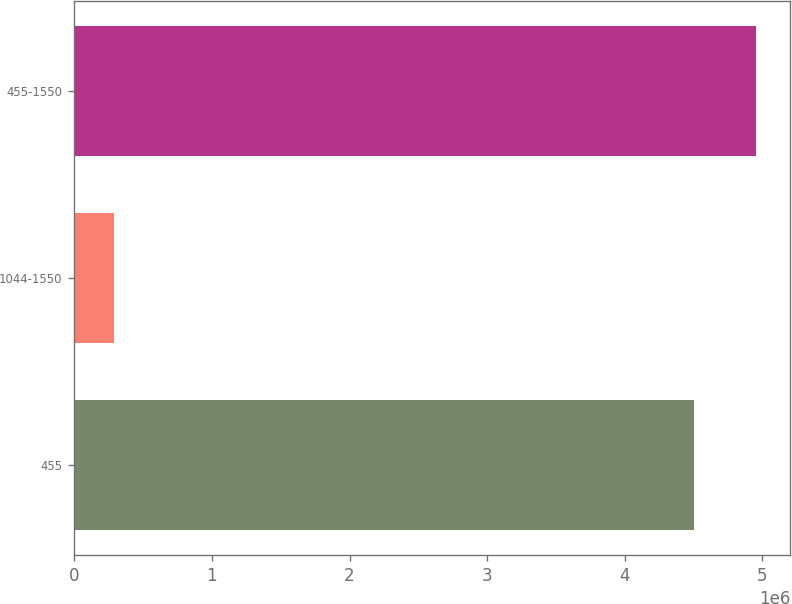Convert chart. <chart><loc_0><loc_0><loc_500><loc_500><bar_chart><fcel>455<fcel>1044-1550<fcel>455-1550<nl><fcel>4.50562e+06<fcel>285325<fcel>4.95618e+06<nl></chart> 